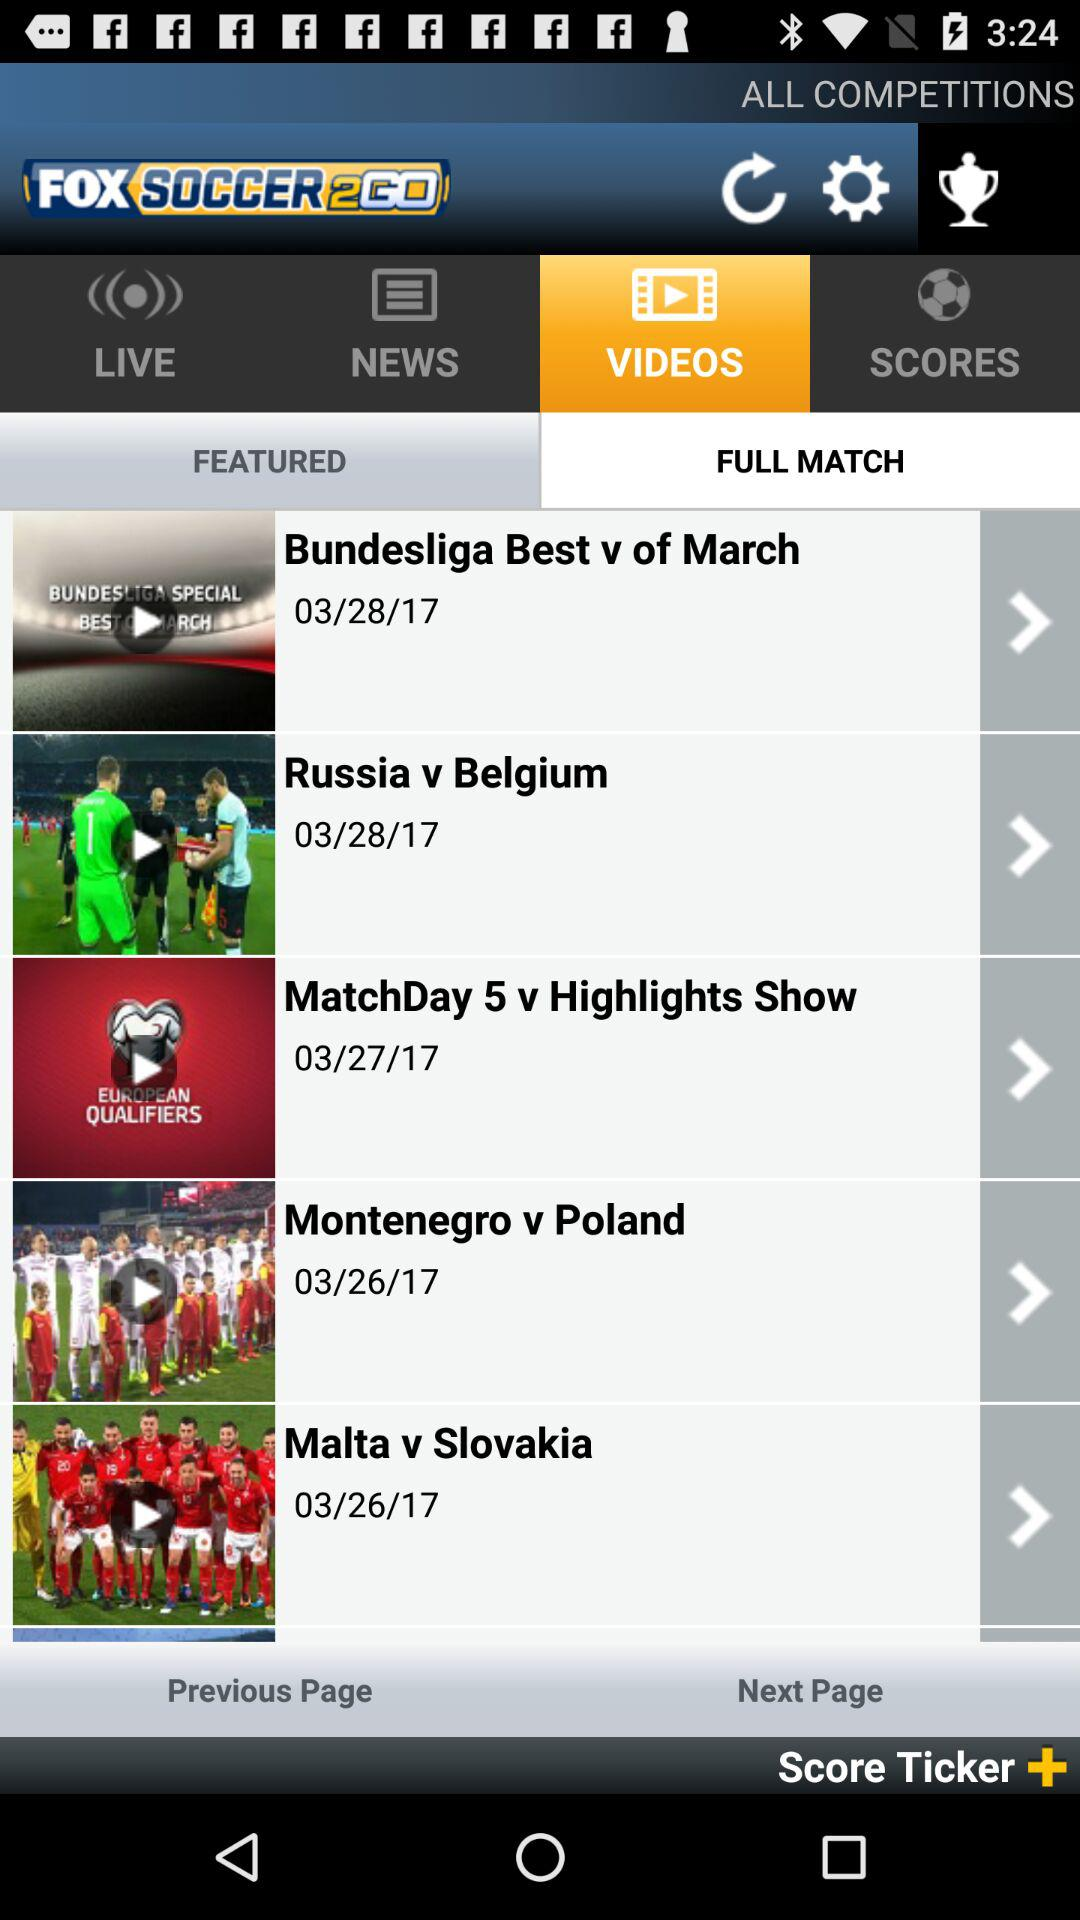What was the date of the "Montenegro v Poland" match? The date of the "Montenegro v Poland" match was March 26, 2017. 